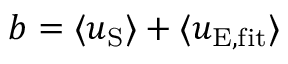<formula> <loc_0><loc_0><loc_500><loc_500>b = \langle u _ { S } \rangle + \langle u _ { E , f i t } \rangle</formula> 